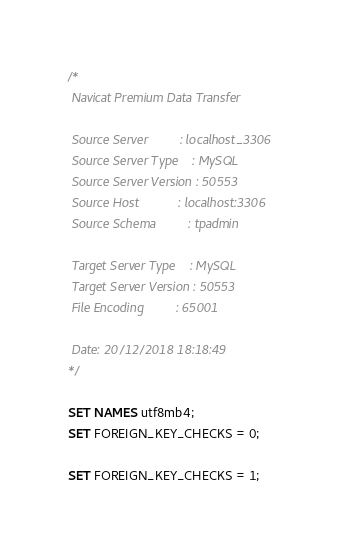<code> <loc_0><loc_0><loc_500><loc_500><_SQL_>
/*
 Navicat Premium Data Transfer

 Source Server         : localhost_3306
 Source Server Type    : MySQL
 Source Server Version : 50553
 Source Host           : localhost:3306
 Source Schema         : tpadmin

 Target Server Type    : MySQL
 Target Server Version : 50553
 File Encoding         : 65001

 Date: 20/12/2018 18:18:49
*/

SET NAMES utf8mb4;
SET FOREIGN_KEY_CHECKS = 0;

SET FOREIGN_KEY_CHECKS = 1;
</code> 